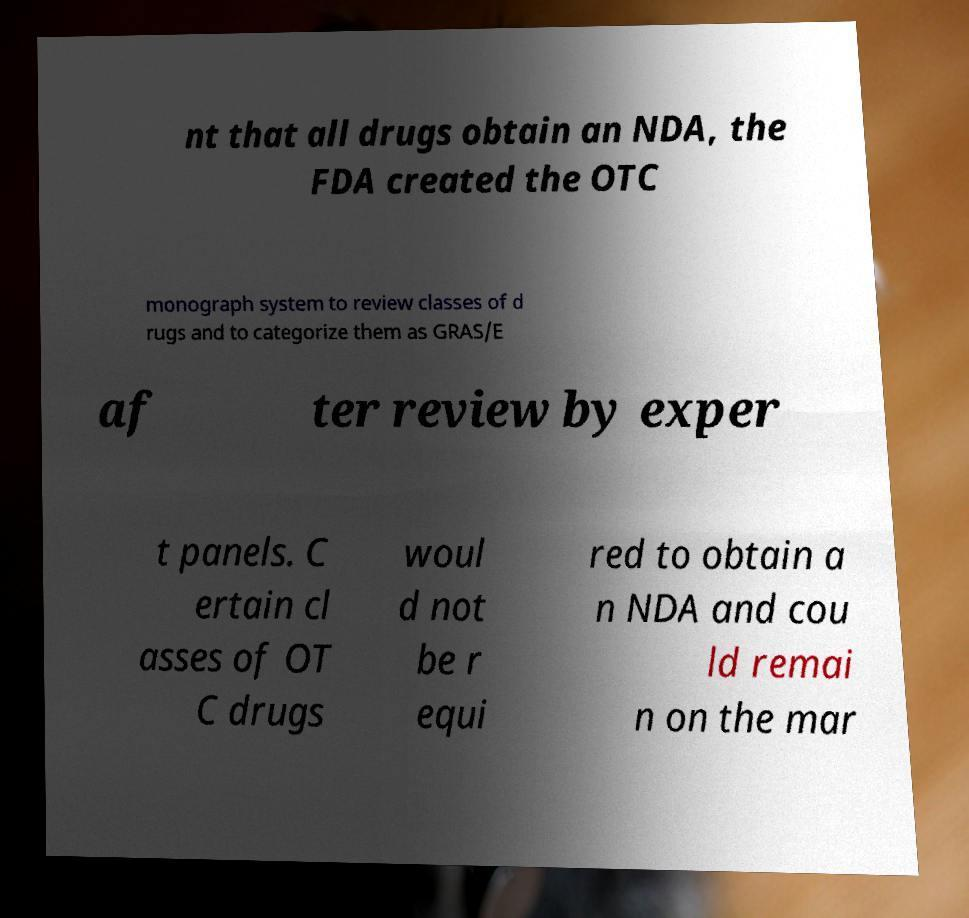Please identify and transcribe the text found in this image. nt that all drugs obtain an NDA, the FDA created the OTC monograph system to review classes of d rugs and to categorize them as GRAS/E af ter review by exper t panels. C ertain cl asses of OT C drugs woul d not be r equi red to obtain a n NDA and cou ld remai n on the mar 